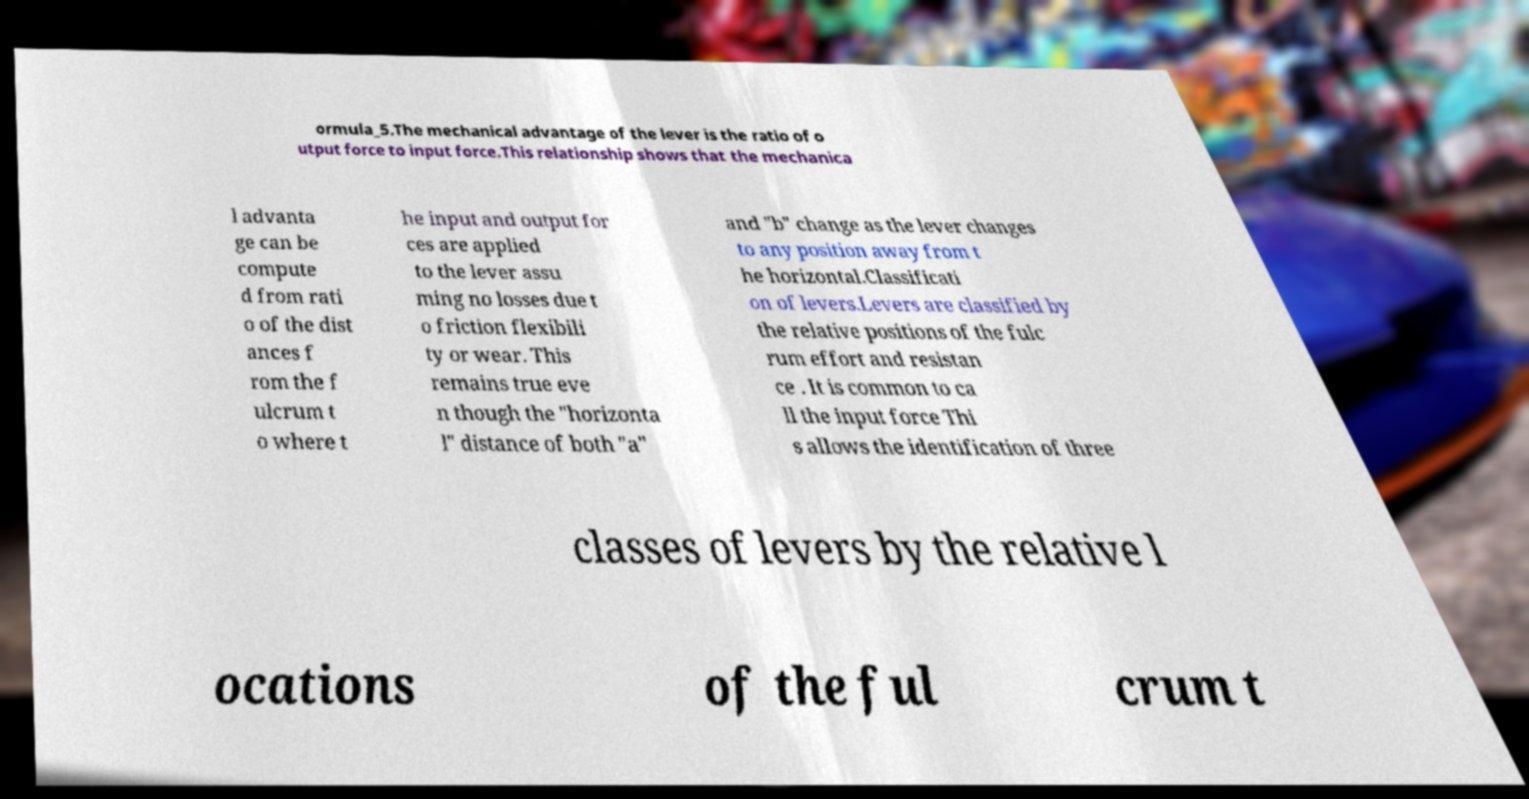I need the written content from this picture converted into text. Can you do that? ormula_5.The mechanical advantage of the lever is the ratio of o utput force to input force.This relationship shows that the mechanica l advanta ge can be compute d from rati o of the dist ances f rom the f ulcrum t o where t he input and output for ces are applied to the lever assu ming no losses due t o friction flexibili ty or wear. This remains true eve n though the "horizonta l" distance of both "a" and "b" change as the lever changes to any position away from t he horizontal.Classificati on of levers.Levers are classified by the relative positions of the fulc rum effort and resistan ce . It is common to ca ll the input force Thi s allows the identification of three classes of levers by the relative l ocations of the ful crum t 